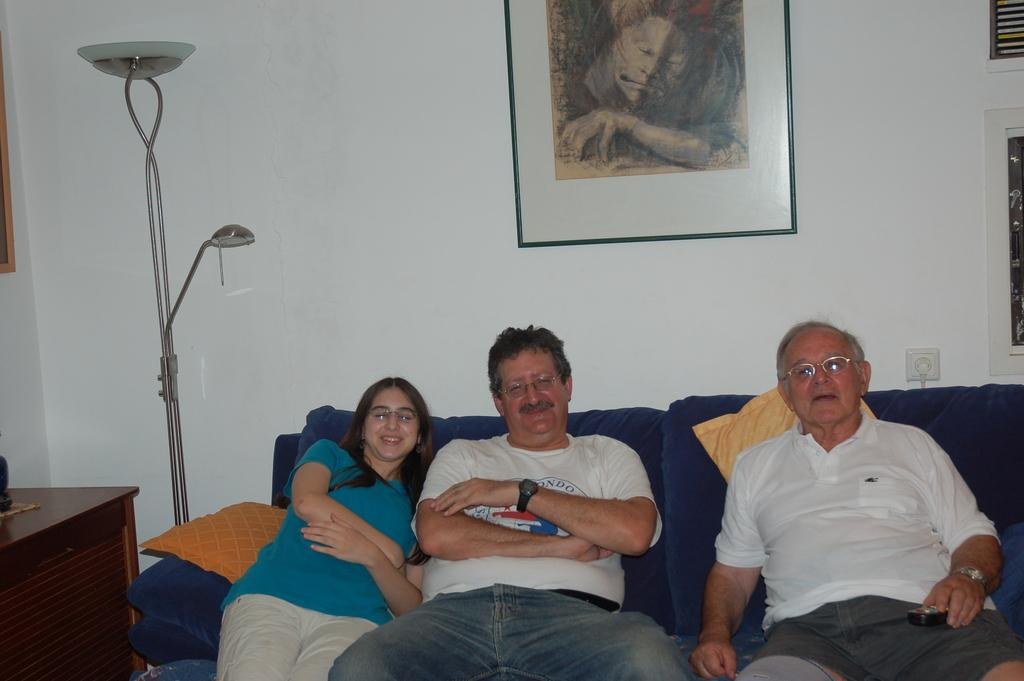How many people are in the image? There are three persons in the image. What are the persons doing in the image? The persons are sitting on a couch and smiling. What can be seen in the background of the image? There is a wall, a photo frame, and a table in the background of the image. What type of bread can be seen on the table in the image? There is no bread present in the image; the table in the background is empty. 